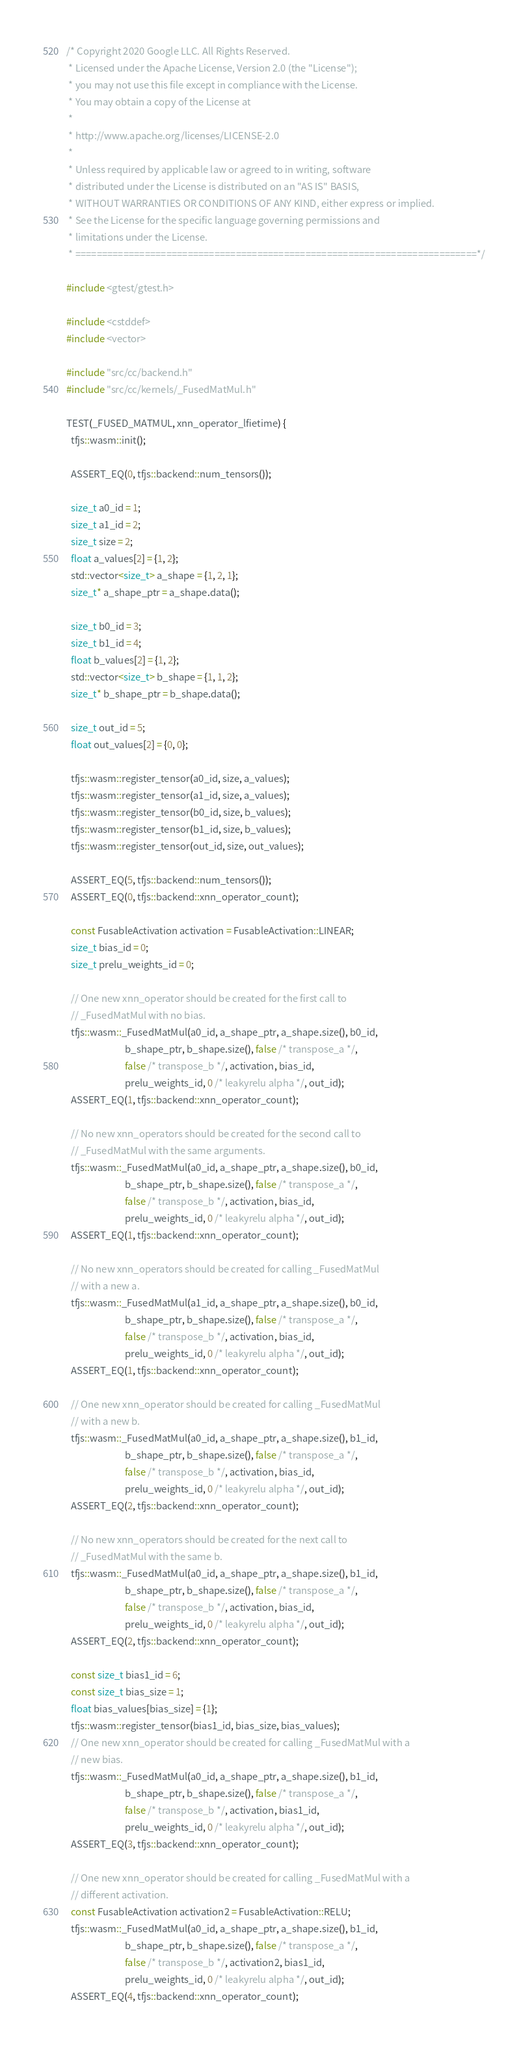<code> <loc_0><loc_0><loc_500><loc_500><_C++_>/* Copyright 2020 Google LLC. All Rights Reserved.
 * Licensed under the Apache License, Version 2.0 (the "License");
 * you may not use this file except in compliance with the License.
 * You may obtain a copy of the License at
 *
 * http://www.apache.org/licenses/LICENSE-2.0
 *
 * Unless required by applicable law or agreed to in writing, software
 * distributed under the License is distributed on an "AS IS" BASIS,
 * WITHOUT WARRANTIES OR CONDITIONS OF ANY KIND, either express or implied.
 * See the License for the specific language governing permissions and
 * limitations under the License.
 * ===========================================================================*/

#include <gtest/gtest.h>

#include <cstddef>
#include <vector>

#include "src/cc/backend.h"
#include "src/cc/kernels/_FusedMatMul.h"

TEST(_FUSED_MATMUL, xnn_operator_lfietime) {
  tfjs::wasm::init();

  ASSERT_EQ(0, tfjs::backend::num_tensors());

  size_t a0_id = 1;
  size_t a1_id = 2;
  size_t size = 2;
  float a_values[2] = {1, 2};
  std::vector<size_t> a_shape = {1, 2, 1};
  size_t* a_shape_ptr = a_shape.data();

  size_t b0_id = 3;
  size_t b1_id = 4;
  float b_values[2] = {1, 2};
  std::vector<size_t> b_shape = {1, 1, 2};
  size_t* b_shape_ptr = b_shape.data();

  size_t out_id = 5;
  float out_values[2] = {0, 0};

  tfjs::wasm::register_tensor(a0_id, size, a_values);
  tfjs::wasm::register_tensor(a1_id, size, a_values);
  tfjs::wasm::register_tensor(b0_id, size, b_values);
  tfjs::wasm::register_tensor(b1_id, size, b_values);
  tfjs::wasm::register_tensor(out_id, size, out_values);

  ASSERT_EQ(5, tfjs::backend::num_tensors());
  ASSERT_EQ(0, tfjs::backend::xnn_operator_count);

  const FusableActivation activation = FusableActivation::LINEAR;
  size_t bias_id = 0;
  size_t prelu_weights_id = 0;

  // One new xnn_operator should be created for the first call to
  // _FusedMatMul with no bias.
  tfjs::wasm::_FusedMatMul(a0_id, a_shape_ptr, a_shape.size(), b0_id,
                           b_shape_ptr, b_shape.size(), false /* transpose_a */,
                           false /* transpose_b */, activation, bias_id,
                           prelu_weights_id, 0 /* leakyrelu alpha */, out_id);
  ASSERT_EQ(1, tfjs::backend::xnn_operator_count);

  // No new xnn_operators should be created for the second call to
  // _FusedMatMul with the same arguments.
  tfjs::wasm::_FusedMatMul(a0_id, a_shape_ptr, a_shape.size(), b0_id,
                           b_shape_ptr, b_shape.size(), false /* transpose_a */,
                           false /* transpose_b */, activation, bias_id,
                           prelu_weights_id, 0 /* leakyrelu alpha */, out_id);
  ASSERT_EQ(1, tfjs::backend::xnn_operator_count);

  // No new xnn_operators should be created for calling _FusedMatMul
  // with a new a.
  tfjs::wasm::_FusedMatMul(a1_id, a_shape_ptr, a_shape.size(), b0_id,
                           b_shape_ptr, b_shape.size(), false /* transpose_a */,
                           false /* transpose_b */, activation, bias_id,
                           prelu_weights_id, 0 /* leakyrelu alpha */, out_id);
  ASSERT_EQ(1, tfjs::backend::xnn_operator_count);

  // One new xnn_operator should be created for calling _FusedMatMul
  // with a new b.
  tfjs::wasm::_FusedMatMul(a0_id, a_shape_ptr, a_shape.size(), b1_id,
                           b_shape_ptr, b_shape.size(), false /* transpose_a */,
                           false /* transpose_b */, activation, bias_id,
                           prelu_weights_id, 0 /* leakyrelu alpha */, out_id);
  ASSERT_EQ(2, tfjs::backend::xnn_operator_count);

  // No new xnn_operators should be created for the next call to
  // _FusedMatMul with the same b.
  tfjs::wasm::_FusedMatMul(a0_id, a_shape_ptr, a_shape.size(), b1_id,
                           b_shape_ptr, b_shape.size(), false /* transpose_a */,
                           false /* transpose_b */, activation, bias_id,
                           prelu_weights_id, 0 /* leakyrelu alpha */, out_id);
  ASSERT_EQ(2, tfjs::backend::xnn_operator_count);

  const size_t bias1_id = 6;
  const size_t bias_size = 1;
  float bias_values[bias_size] = {1};
  tfjs::wasm::register_tensor(bias1_id, bias_size, bias_values);
  // One new xnn_operator should be created for calling _FusedMatMul with a
  // new bias.
  tfjs::wasm::_FusedMatMul(a0_id, a_shape_ptr, a_shape.size(), b1_id,
                           b_shape_ptr, b_shape.size(), false /* transpose_a */,
                           false /* transpose_b */, activation, bias1_id,
                           prelu_weights_id, 0 /* leakyrelu alpha */, out_id);
  ASSERT_EQ(3, tfjs::backend::xnn_operator_count);

  // One new xnn_operator should be created for calling _FusedMatMul with a
  // different activation.
  const FusableActivation activation2 = FusableActivation::RELU;
  tfjs::wasm::_FusedMatMul(a0_id, a_shape_ptr, a_shape.size(), b1_id,
                           b_shape_ptr, b_shape.size(), false /* transpose_a */,
                           false /* transpose_b */, activation2, bias1_id,
                           prelu_weights_id, 0 /* leakyrelu alpha */, out_id);
  ASSERT_EQ(4, tfjs::backend::xnn_operator_count);
</code> 